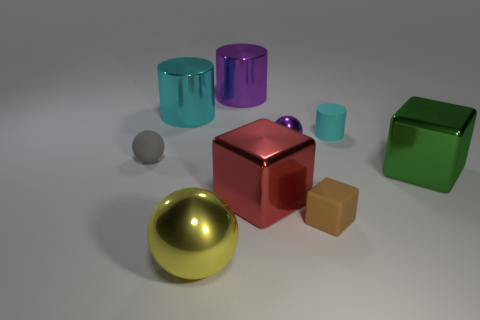The purple cylinder that is the same material as the large yellow ball is what size?
Offer a very short reply. Large. There is a cyan object that is right of the brown matte object; is its size the same as the metal ball that is left of the purple shiny cylinder?
Make the answer very short. No. What number of objects are big metallic things behind the small purple ball or tiny purple objects?
Your answer should be compact. 3. Are there fewer small purple spheres than big brown matte objects?
Your answer should be very brief. No. There is a object that is right of the rubber object behind the ball behind the gray ball; what shape is it?
Offer a terse response. Cube. Is there a cyan cube?
Keep it short and to the point. No. There is a brown rubber cube; is it the same size as the cyan cylinder in front of the large cyan metallic cylinder?
Keep it short and to the point. Yes. There is a object on the right side of the cyan matte cylinder; is there a tiny gray rubber thing that is behind it?
Your response must be concise. Yes. There is a tiny thing that is both behind the tiny brown matte cube and right of the small shiny object; what material is it?
Your response must be concise. Rubber. The small thing to the left of the large shiny cube in front of the block on the right side of the tiny cyan rubber cylinder is what color?
Provide a short and direct response. Gray. 